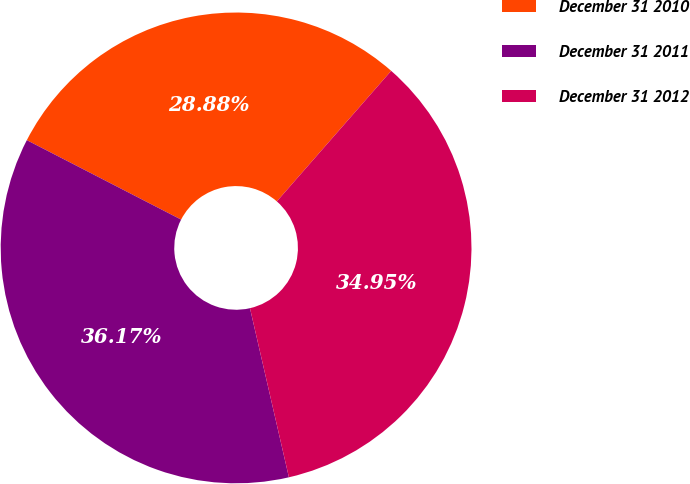<chart> <loc_0><loc_0><loc_500><loc_500><pie_chart><fcel>December 31 2010<fcel>December 31 2011<fcel>December 31 2012<nl><fcel>28.88%<fcel>36.17%<fcel>34.95%<nl></chart> 